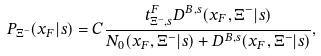Convert formula to latex. <formula><loc_0><loc_0><loc_500><loc_500>P _ { \Xi ^ { - } } ( x _ { F } | s ) = C \frac { t ^ { F } _ { \Xi ^ { - } , s } D ^ { B , s } ( x _ { F } , \Xi ^ { - } | s ) } { N _ { 0 } ( x _ { F } , \Xi ^ { - } | s ) + D ^ { B , s } ( x _ { F } , \Xi ^ { - } | s ) } ,</formula> 